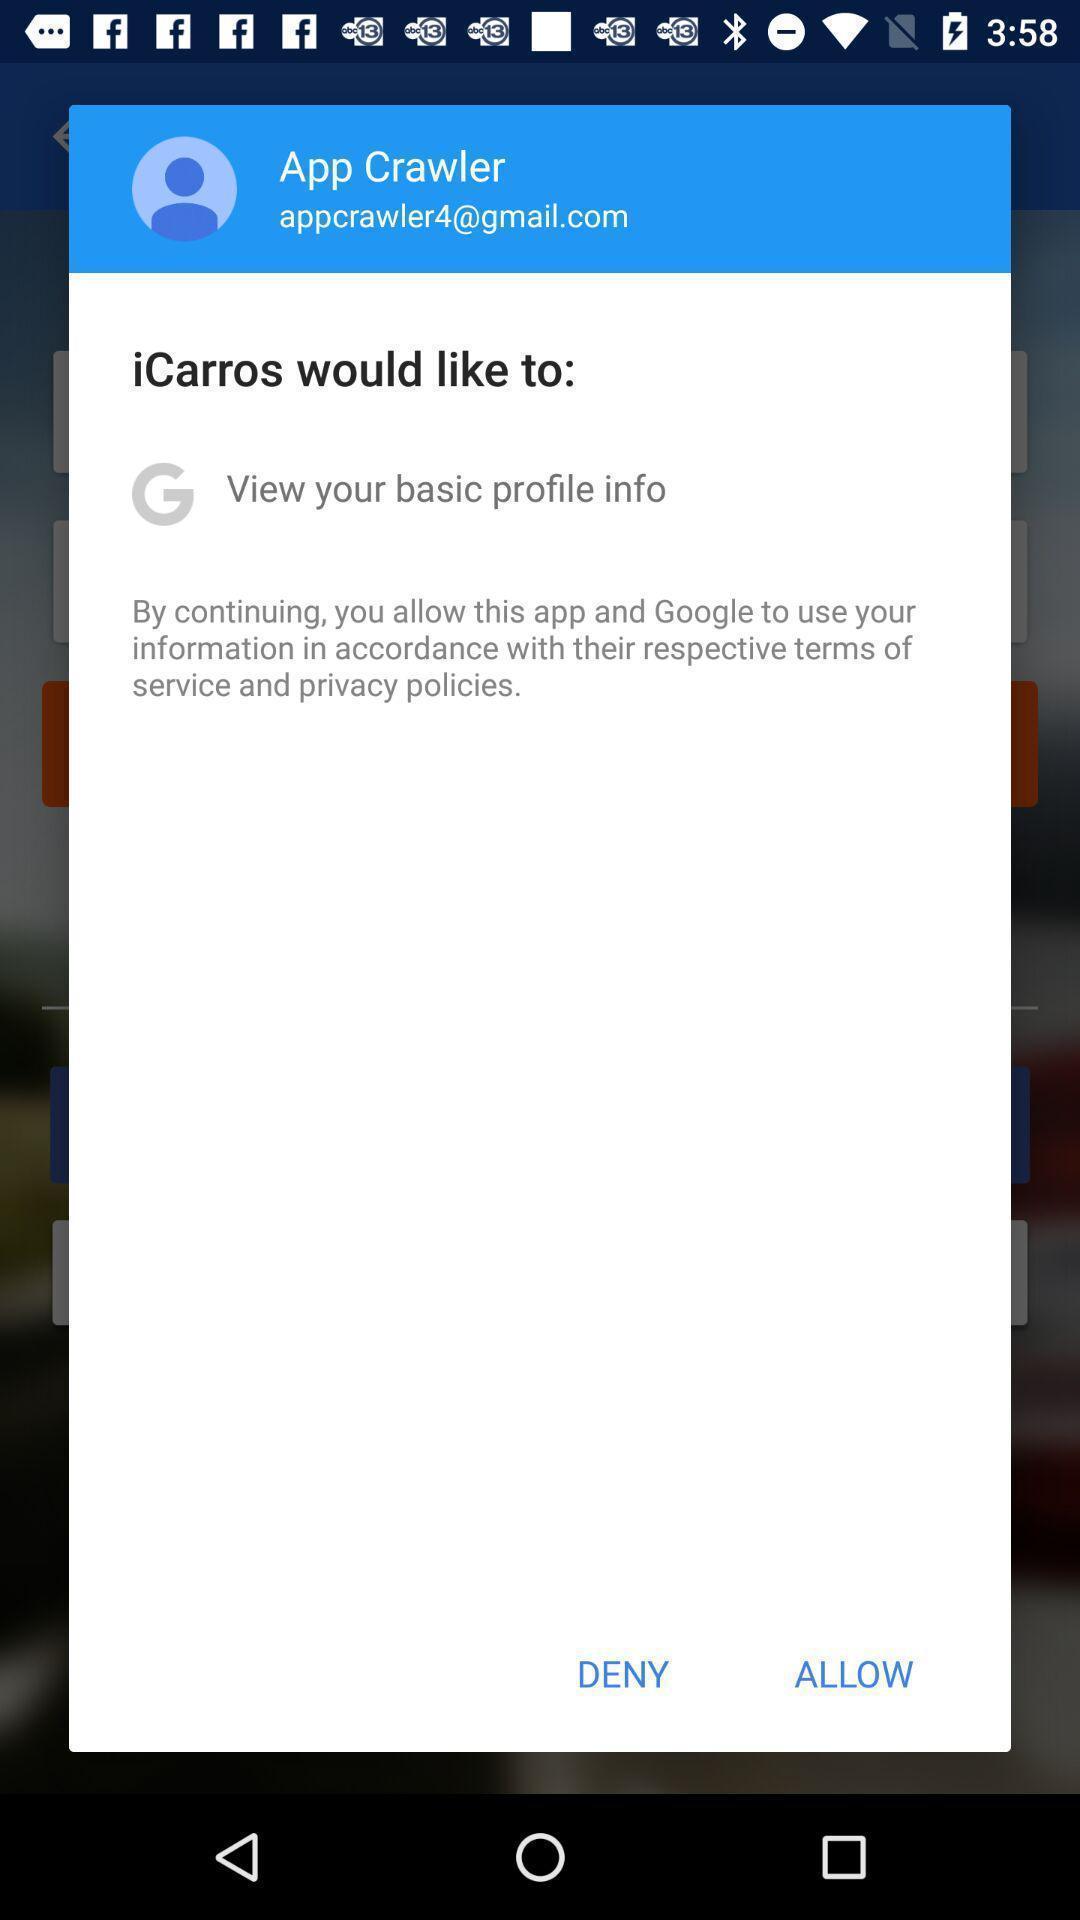Tell me what you see in this picture. Pop-up asking to allow the access. 